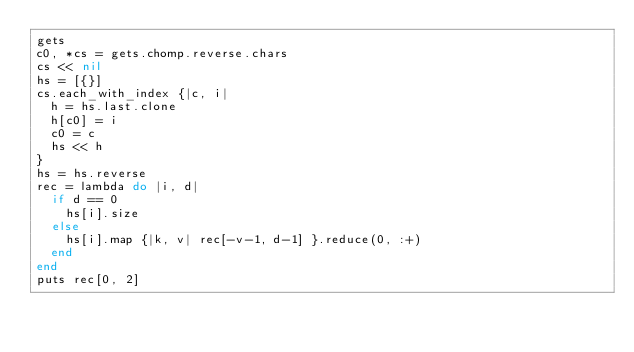<code> <loc_0><loc_0><loc_500><loc_500><_Ruby_>gets
c0, *cs = gets.chomp.reverse.chars
cs << nil
hs = [{}]
cs.each_with_index {|c, i|
  h = hs.last.clone
  h[c0] = i
  c0 = c
  hs << h
}
hs = hs.reverse
rec = lambda do |i, d|
  if d == 0
    hs[i].size
  else
    hs[i].map {|k, v| rec[-v-1, d-1] }.reduce(0, :+)
  end
end
puts rec[0, 2]
</code> 